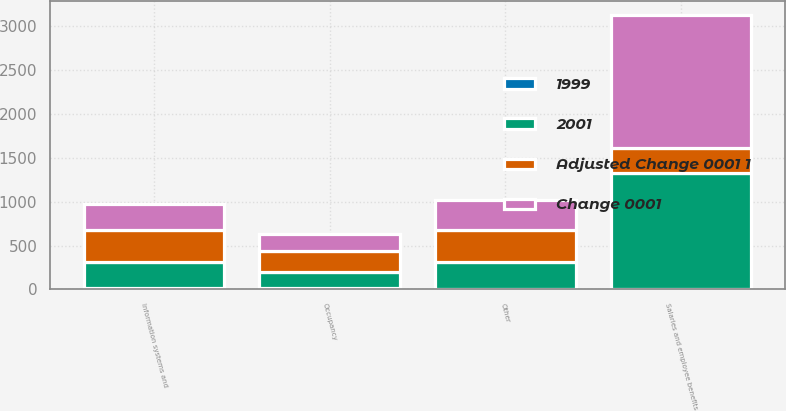Convert chart to OTSL. <chart><loc_0><loc_0><loc_500><loc_500><stacked_bar_chart><ecel><fcel>Salaries and employee benefits<fcel>Information systems and<fcel>Occupancy<fcel>Other<nl><fcel>Adjusted Change 0001 1<fcel>287<fcel>365<fcel>229<fcel>363<nl><fcel>Change 0001<fcel>1524<fcel>305<fcel>201<fcel>346<nl><fcel>2001<fcel>1313<fcel>287<fcel>188<fcel>311<nl><fcel>1999<fcel>9<fcel>20<fcel>15<fcel>5<nl></chart> 